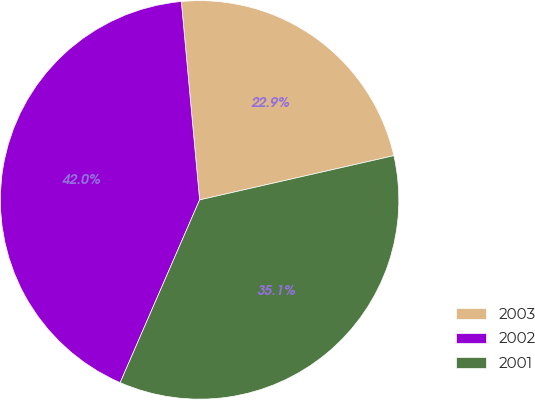Convert chart. <chart><loc_0><loc_0><loc_500><loc_500><pie_chart><fcel>2003<fcel>2002<fcel>2001<nl><fcel>22.9%<fcel>42.01%<fcel>35.09%<nl></chart> 